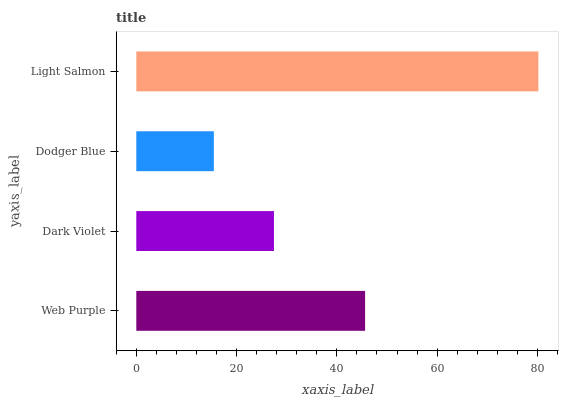Is Dodger Blue the minimum?
Answer yes or no. Yes. Is Light Salmon the maximum?
Answer yes or no. Yes. Is Dark Violet the minimum?
Answer yes or no. No. Is Dark Violet the maximum?
Answer yes or no. No. Is Web Purple greater than Dark Violet?
Answer yes or no. Yes. Is Dark Violet less than Web Purple?
Answer yes or no. Yes. Is Dark Violet greater than Web Purple?
Answer yes or no. No. Is Web Purple less than Dark Violet?
Answer yes or no. No. Is Web Purple the high median?
Answer yes or no. Yes. Is Dark Violet the low median?
Answer yes or no. Yes. Is Light Salmon the high median?
Answer yes or no. No. Is Web Purple the low median?
Answer yes or no. No. 